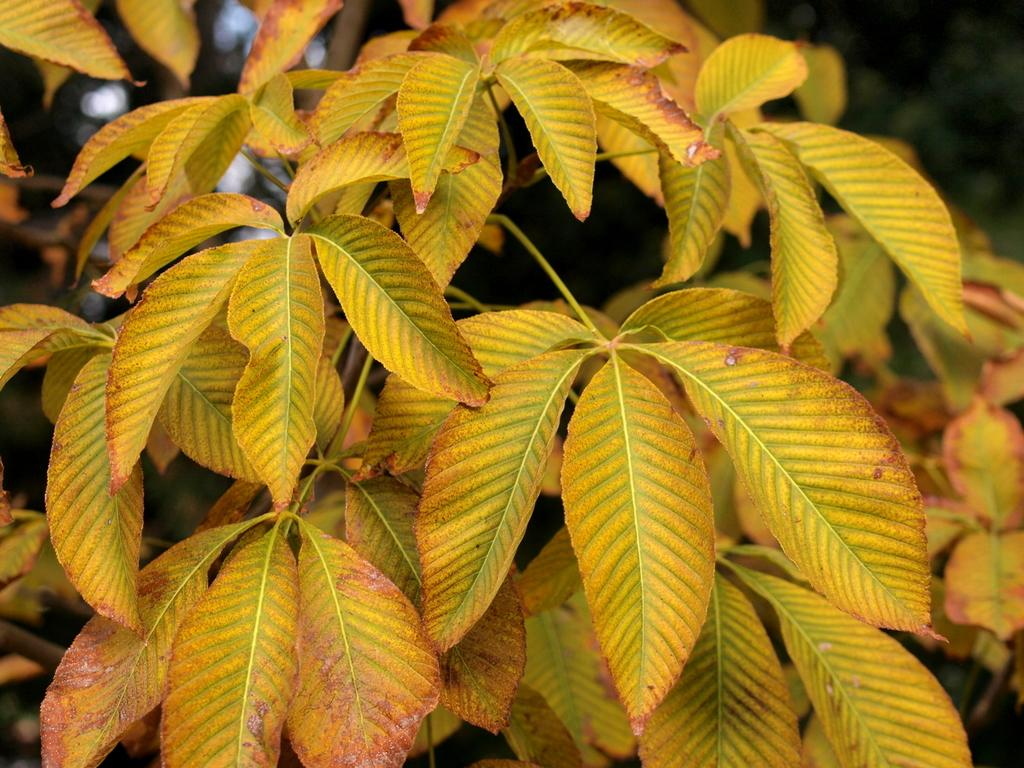What type of vegetation can be seen in the image? There are leaves in the image. What type of nail is being used to secure the property in the image? There is no nail or property present in the image; it only features leaves. 